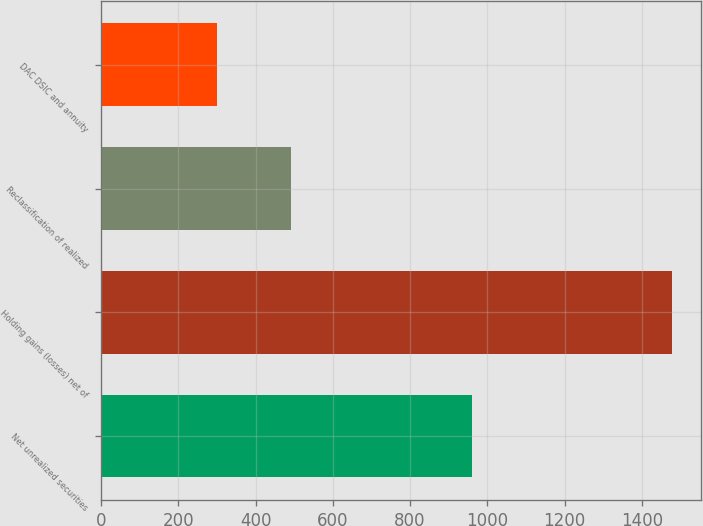Convert chart. <chart><loc_0><loc_0><loc_500><loc_500><bar_chart><fcel>Net unrealized securities<fcel>Holding gains (losses) net of<fcel>Reclassification of realized<fcel>DAC DSIC and annuity<nl><fcel>961<fcel>1479<fcel>492<fcel>299.1<nl></chart> 